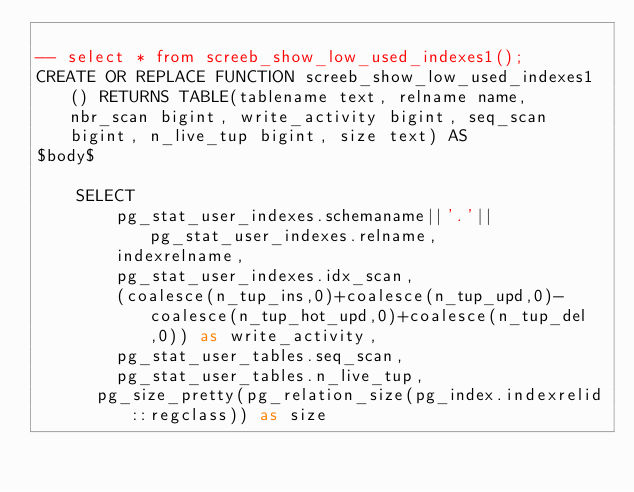<code> <loc_0><loc_0><loc_500><loc_500><_SQL_>
-- select * from screeb_show_low_used_indexes1();
CREATE OR REPLACE FUNCTION screeb_show_low_used_indexes1() RETURNS TABLE(tablename text, relname name, nbr_scan bigint, write_activity bigint, seq_scan bigint, n_live_tup bigint, size text) AS
$body$

    SELECT
        pg_stat_user_indexes.schemaname||'.'||pg_stat_user_indexes.relname,
        indexrelname,
        pg_stat_user_indexes.idx_scan,
        (coalesce(n_tup_ins,0)+coalesce(n_tup_upd,0)-coalesce(n_tup_hot_upd,0)+coalesce(n_tup_del,0)) as write_activity,
        pg_stat_user_tables.seq_scan,
        pg_stat_user_tables.n_live_tup,
      pg_size_pretty(pg_relation_size(pg_index.indexrelid::regclass)) as size</code> 